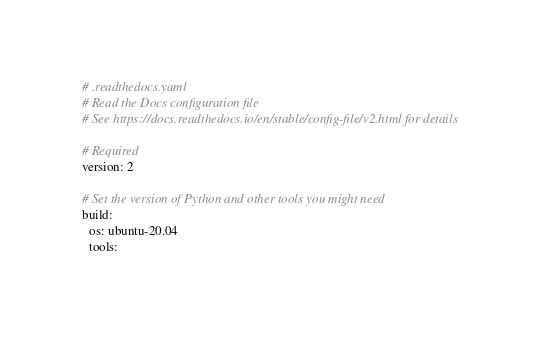Convert code to text. <code><loc_0><loc_0><loc_500><loc_500><_YAML_># .readthedocs.yaml
# Read the Docs configuration file
# See https://docs.readthedocs.io/en/stable/config-file/v2.html for details

# Required
version: 2

# Set the version of Python and other tools you might need
build:
  os: ubuntu-20.04
  tools:</code> 